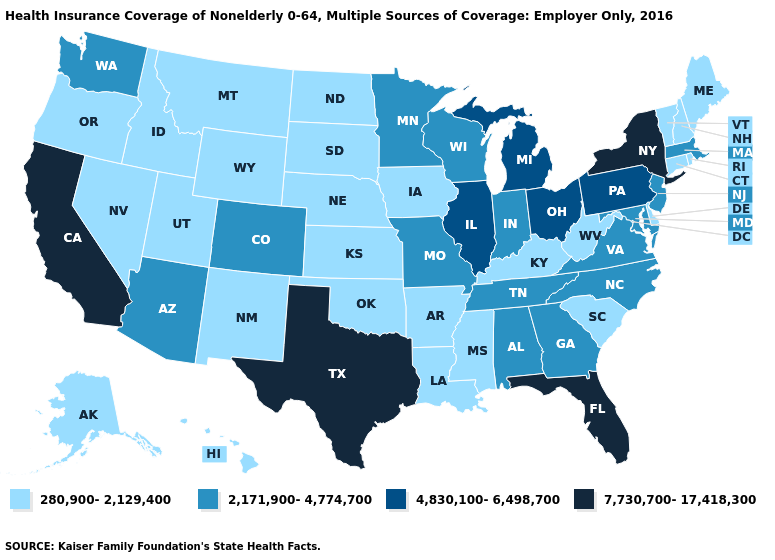Name the states that have a value in the range 2,171,900-4,774,700?
Quick response, please. Alabama, Arizona, Colorado, Georgia, Indiana, Maryland, Massachusetts, Minnesota, Missouri, New Jersey, North Carolina, Tennessee, Virginia, Washington, Wisconsin. Name the states that have a value in the range 280,900-2,129,400?
Short answer required. Alaska, Arkansas, Connecticut, Delaware, Hawaii, Idaho, Iowa, Kansas, Kentucky, Louisiana, Maine, Mississippi, Montana, Nebraska, Nevada, New Hampshire, New Mexico, North Dakota, Oklahoma, Oregon, Rhode Island, South Carolina, South Dakota, Utah, Vermont, West Virginia, Wyoming. Does the first symbol in the legend represent the smallest category?
Keep it brief. Yes. What is the highest value in the West ?
Short answer required. 7,730,700-17,418,300. What is the value of Indiana?
Give a very brief answer. 2,171,900-4,774,700. Among the states that border Oklahoma , which have the highest value?
Short answer required. Texas. What is the value of California?
Answer briefly. 7,730,700-17,418,300. Does Connecticut have the highest value in the USA?
Answer briefly. No. Among the states that border Ohio , which have the highest value?
Concise answer only. Michigan, Pennsylvania. Among the states that border Virginia , which have the lowest value?
Concise answer only. Kentucky, West Virginia. Does New York have the highest value in the USA?
Short answer required. Yes. Among the states that border Colorado , does Arizona have the highest value?
Concise answer only. Yes. Among the states that border Connecticut , which have the lowest value?
Concise answer only. Rhode Island. What is the value of New Mexico?
Write a very short answer. 280,900-2,129,400. Name the states that have a value in the range 2,171,900-4,774,700?
Concise answer only. Alabama, Arizona, Colorado, Georgia, Indiana, Maryland, Massachusetts, Minnesota, Missouri, New Jersey, North Carolina, Tennessee, Virginia, Washington, Wisconsin. 